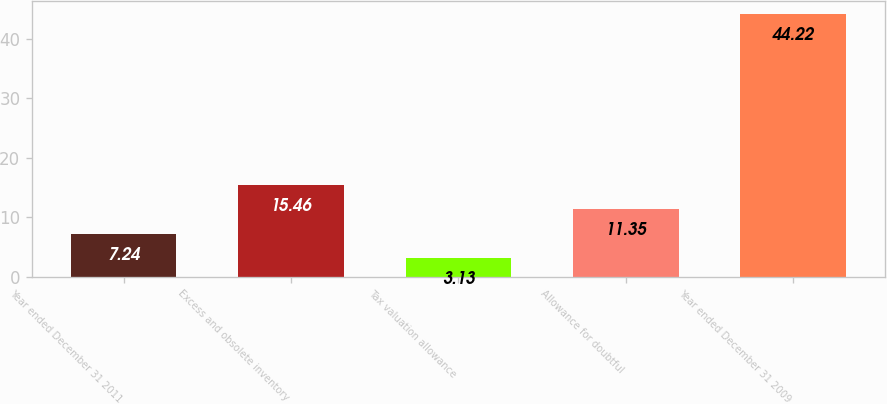Convert chart to OTSL. <chart><loc_0><loc_0><loc_500><loc_500><bar_chart><fcel>Year ended December 31 2011<fcel>Excess and obsolete inventory<fcel>Tax valuation allowance<fcel>Allowance for doubtful<fcel>Year ended December 31 2009<nl><fcel>7.24<fcel>15.46<fcel>3.13<fcel>11.35<fcel>44.22<nl></chart> 